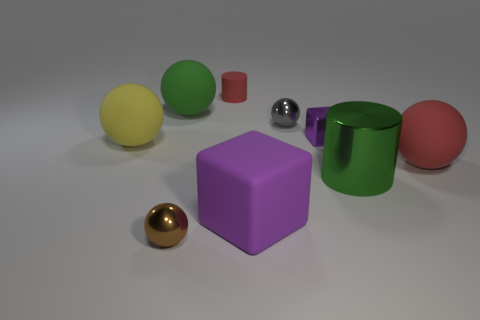What number of objects are tiny balls or purple cubes in front of the green metallic object?
Keep it short and to the point. 3. There is a purple block that is behind the big block; is its size the same as the metal ball that is in front of the yellow rubber thing?
Provide a succinct answer. Yes. Is there a small gray ball made of the same material as the brown sphere?
Offer a terse response. Yes. There is a large purple object; what shape is it?
Provide a succinct answer. Cube. The large red rubber thing that is on the right side of the cylinder behind the big red rubber object is what shape?
Make the answer very short. Sphere. How many other things are there of the same shape as the small red rubber object?
Your response must be concise. 1. There is a green object that is on the right side of the tiny brown object that is to the left of the purple shiny thing; how big is it?
Ensure brevity in your answer.  Large. Is there a red sphere?
Offer a very short reply. Yes. What number of matte objects are behind the red object in front of the large green rubber object?
Provide a short and direct response. 3. There is a large green thing left of the small brown ball; what is its shape?
Keep it short and to the point. Sphere. 